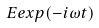Convert formula to latex. <formula><loc_0><loc_0><loc_500><loc_500>E e x p ( - i \omega t )</formula> 